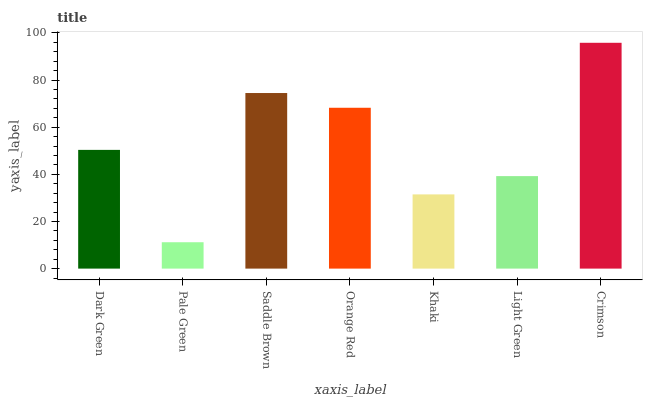Is Pale Green the minimum?
Answer yes or no. Yes. Is Crimson the maximum?
Answer yes or no. Yes. Is Saddle Brown the minimum?
Answer yes or no. No. Is Saddle Brown the maximum?
Answer yes or no. No. Is Saddle Brown greater than Pale Green?
Answer yes or no. Yes. Is Pale Green less than Saddle Brown?
Answer yes or no. Yes. Is Pale Green greater than Saddle Brown?
Answer yes or no. No. Is Saddle Brown less than Pale Green?
Answer yes or no. No. Is Dark Green the high median?
Answer yes or no. Yes. Is Dark Green the low median?
Answer yes or no. Yes. Is Khaki the high median?
Answer yes or no. No. Is Crimson the low median?
Answer yes or no. No. 